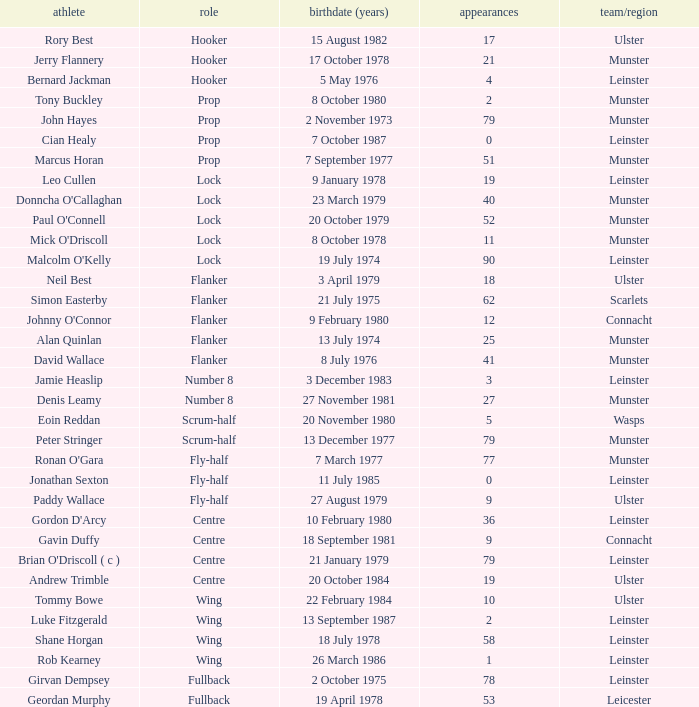Paddy Wallace who plays the position of fly-half has how many Caps? 9.0. Would you be able to parse every entry in this table? {'header': ['athlete', 'role', 'birthdate (years)', 'appearances', 'team/region'], 'rows': [['Rory Best', 'Hooker', '15 August 1982', '17', 'Ulster'], ['Jerry Flannery', 'Hooker', '17 October 1978', '21', 'Munster'], ['Bernard Jackman', 'Hooker', '5 May 1976', '4', 'Leinster'], ['Tony Buckley', 'Prop', '8 October 1980', '2', 'Munster'], ['John Hayes', 'Prop', '2 November 1973', '79', 'Munster'], ['Cian Healy', 'Prop', '7 October 1987', '0', 'Leinster'], ['Marcus Horan', 'Prop', '7 September 1977', '51', 'Munster'], ['Leo Cullen', 'Lock', '9 January 1978', '19', 'Leinster'], ["Donncha O'Callaghan", 'Lock', '23 March 1979', '40', 'Munster'], ["Paul O'Connell", 'Lock', '20 October 1979', '52', 'Munster'], ["Mick O'Driscoll", 'Lock', '8 October 1978', '11', 'Munster'], ["Malcolm O'Kelly", 'Lock', '19 July 1974', '90', 'Leinster'], ['Neil Best', 'Flanker', '3 April 1979', '18', 'Ulster'], ['Simon Easterby', 'Flanker', '21 July 1975', '62', 'Scarlets'], ["Johnny O'Connor", 'Flanker', '9 February 1980', '12', 'Connacht'], ['Alan Quinlan', 'Flanker', '13 July 1974', '25', 'Munster'], ['David Wallace', 'Flanker', '8 July 1976', '41', 'Munster'], ['Jamie Heaslip', 'Number 8', '3 December 1983', '3', 'Leinster'], ['Denis Leamy', 'Number 8', '27 November 1981', '27', 'Munster'], ['Eoin Reddan', 'Scrum-half', '20 November 1980', '5', 'Wasps'], ['Peter Stringer', 'Scrum-half', '13 December 1977', '79', 'Munster'], ["Ronan O'Gara", 'Fly-half', '7 March 1977', '77', 'Munster'], ['Jonathan Sexton', 'Fly-half', '11 July 1985', '0', 'Leinster'], ['Paddy Wallace', 'Fly-half', '27 August 1979', '9', 'Ulster'], ["Gordon D'Arcy", 'Centre', '10 February 1980', '36', 'Leinster'], ['Gavin Duffy', 'Centre', '18 September 1981', '9', 'Connacht'], ["Brian O'Driscoll ( c )", 'Centre', '21 January 1979', '79', 'Leinster'], ['Andrew Trimble', 'Centre', '20 October 1984', '19', 'Ulster'], ['Tommy Bowe', 'Wing', '22 February 1984', '10', 'Ulster'], ['Luke Fitzgerald', 'Wing', '13 September 1987', '2', 'Leinster'], ['Shane Horgan', 'Wing', '18 July 1978', '58', 'Leinster'], ['Rob Kearney', 'Wing', '26 March 1986', '1', 'Leinster'], ['Girvan Dempsey', 'Fullback', '2 October 1975', '78', 'Leinster'], ['Geordan Murphy', 'Fullback', '19 April 1978', '53', 'Leicester']]} 